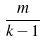<formula> <loc_0><loc_0><loc_500><loc_500>\frac { m } { k - 1 }</formula> 